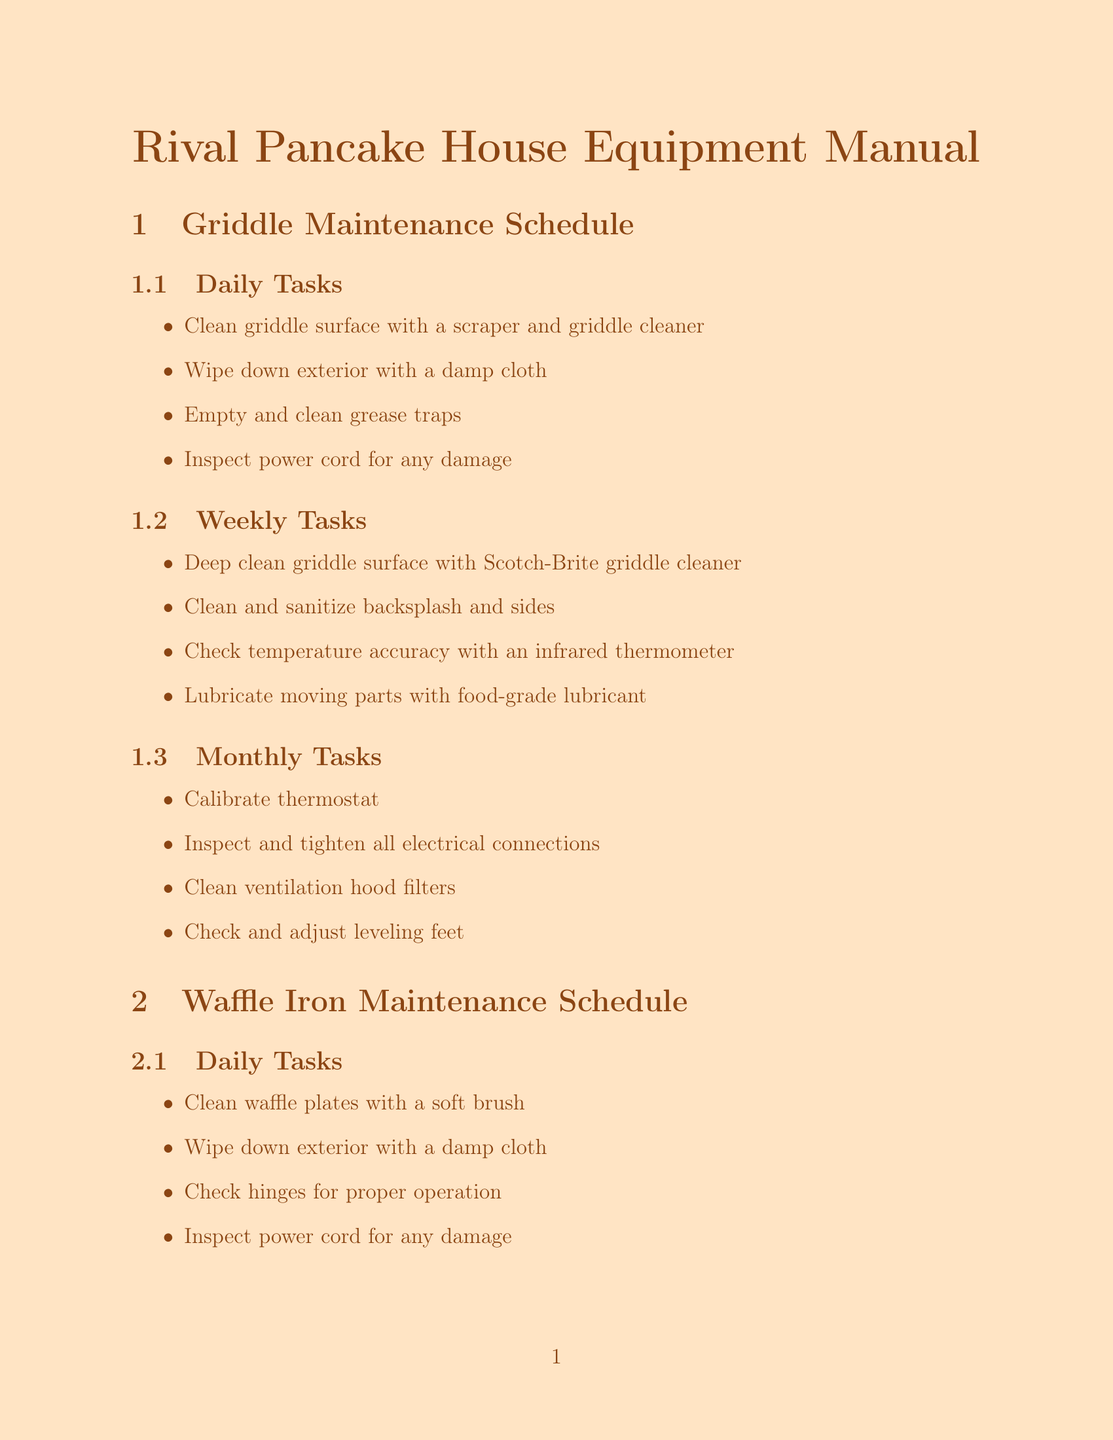What are the daily tasks for griddle maintenance? The daily tasks for griddle maintenance are listed in the document under the Griddle Maintenance Schedule section.
Answer: Clean griddle surface with a scraper and griddle cleaner, Wipe down exterior with a damp cloth, Empty and clean grease traps, Inspect power cord for any damage What is a possible cause of uneven heating? This problem is addressed in the Griddle Troubleshooting Guide, which lists possible causes for uneven heating.
Answer: Faulty heating element How often should you deep clean waffle plates? The frequency of tasks for waffle iron maintenance is specified in the Waffle Iron Maintenance Schedule.
Answer: Weekly What type of cleaning solution is recommended for griddles? The document mentions cleaning solutions under the Recommended Equipment section.
Answer: 3M Scotch-Brite Griddle Cleaner What is one consideration for cold weather? The document lists specific considerations for operating in cold weather in the Canadian context.
Answer: Ensure proper warm-up time for equipment in cold Canadian winters to prevent uneven heating and potential damage What should be done if waffles are sticking to the plates? The Waffle Iron Troubleshooting Guide provides solutions for common problems, including this one.
Answer: Apply vegetable oil to plates before each use 